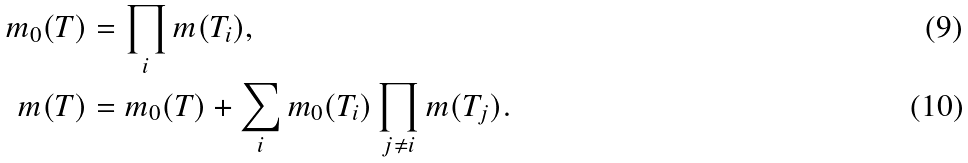Convert formula to latex. <formula><loc_0><loc_0><loc_500><loc_500>m _ { 0 } ( T ) & = \prod _ { i } m ( T _ { i } ) , \\ m ( T ) & = m _ { 0 } ( T ) + \sum _ { i } m _ { 0 } ( T _ { i } ) \prod _ { j \neq i } m ( T _ { j } ) .</formula> 